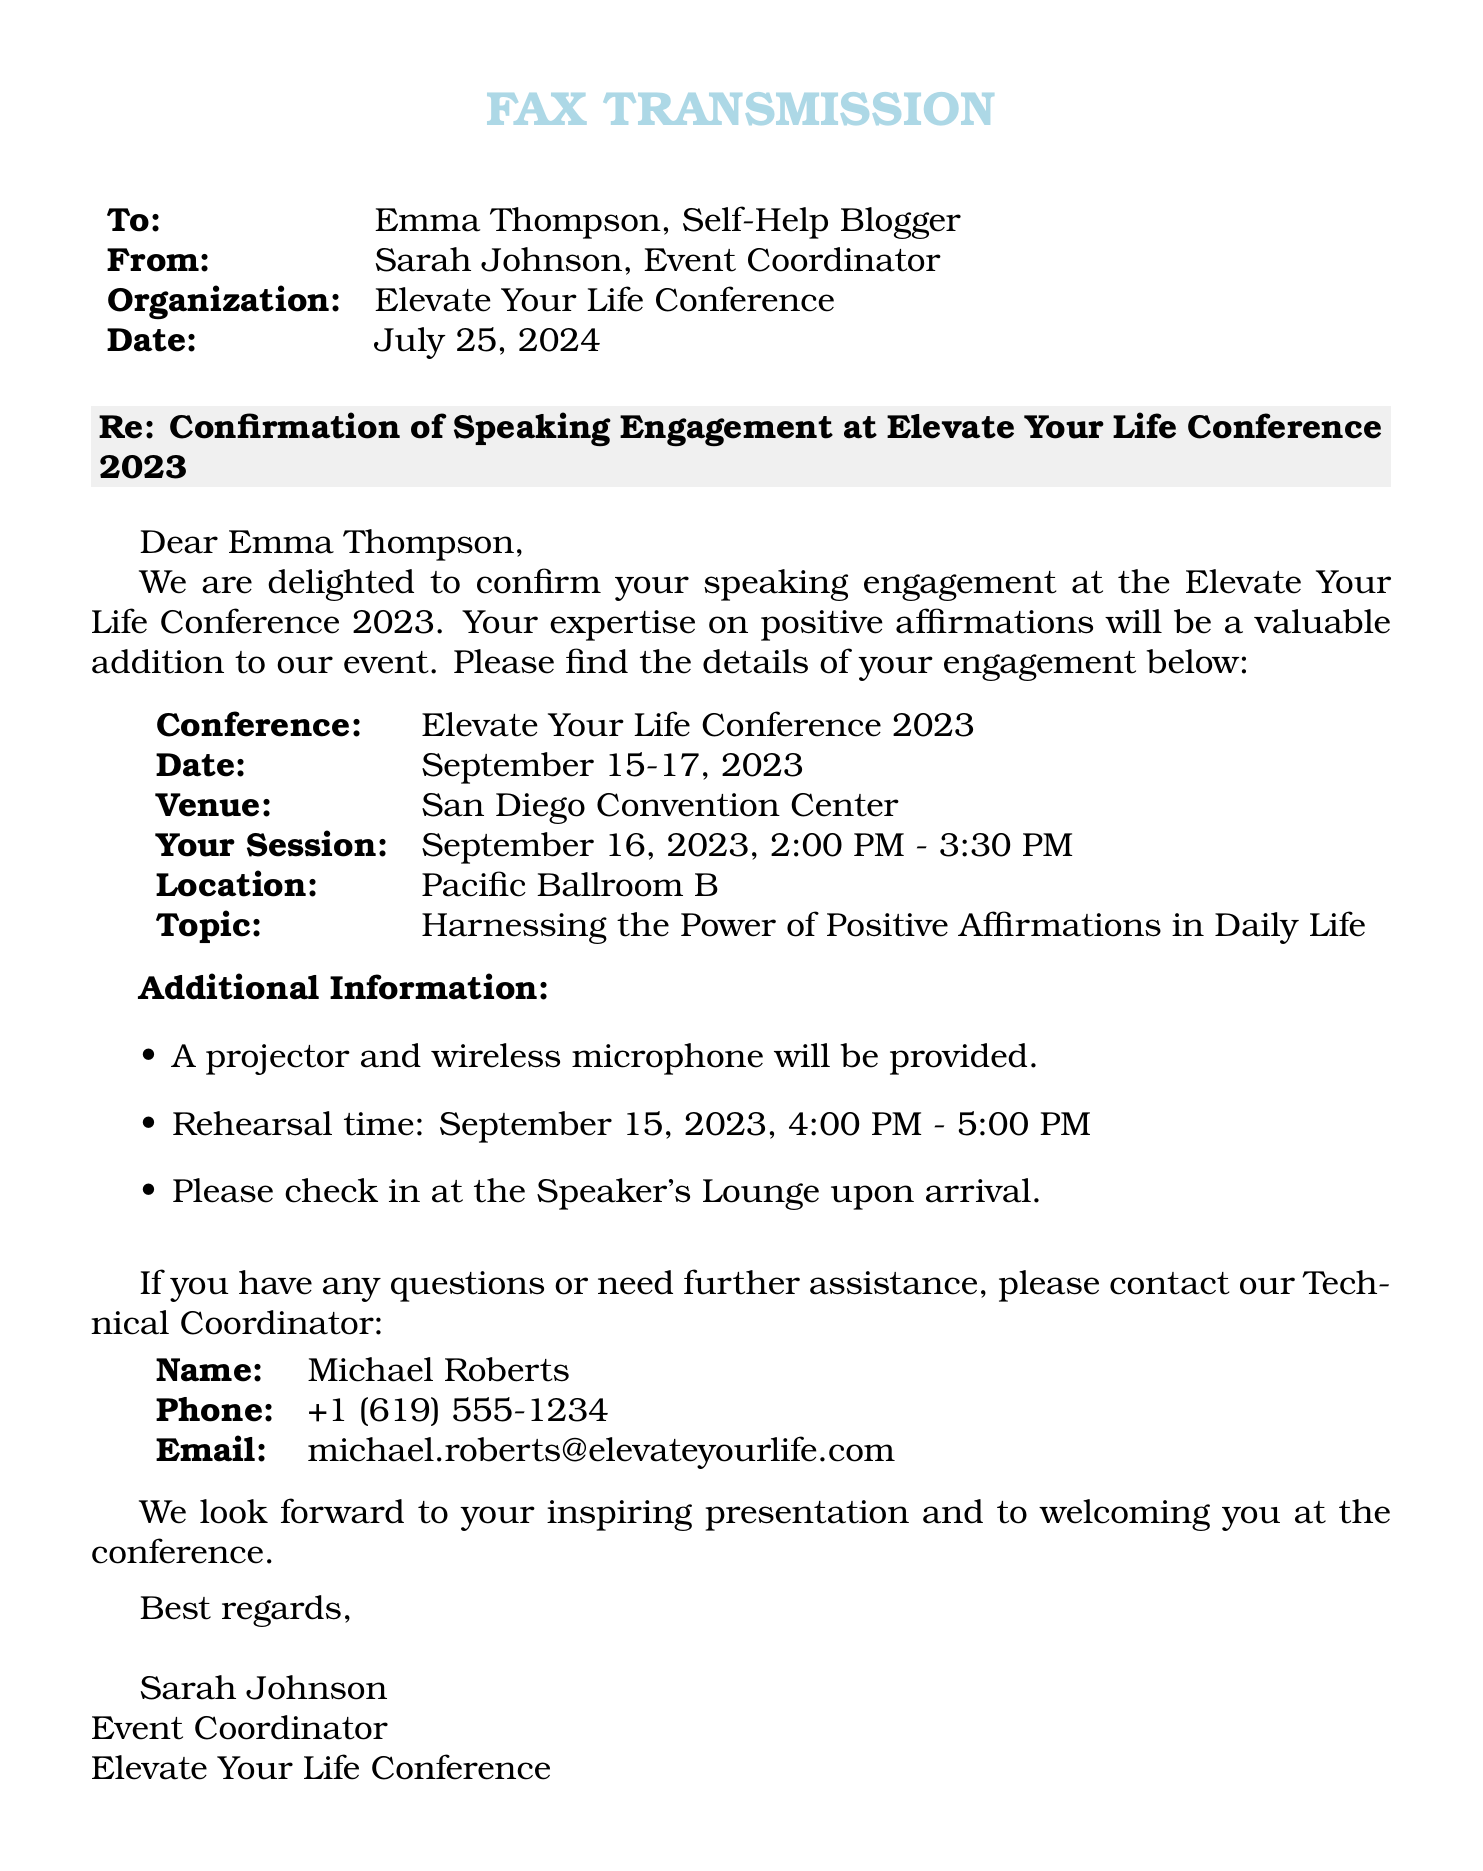What is the date of the conference? The conference is scheduled for September 15-17, 2023.
Answer: September 15-17, 2023 What is the topic of your session? The topic listed for the session is "Harnessing the Power of Positive Affirmations in Daily Life."
Answer: Harnessing the Power of Positive Affirmations in Daily Life What time is your session? The session is from 2:00 PM to 3:30 PM on September 16, 2023.
Answer: 2:00 PM - 3:30 PM Where will the session take place? The location of the session is specified as Pacific Ballroom B.
Answer: Pacific Ballroom B Who is the Technical Coordinator? The document provides the name of the Technical Coordinator as Michael Roberts.
Answer: Michael Roberts What equipment will be provided for the session? A projector and a wireless microphone are mentioned as provided equipment.
Answer: Projector and wireless microphone When is the rehearsal time? The rehearsal time is stated as September 15, 2023, from 4:00 PM to 5:00 PM.
Answer: September 15, 2023, 4:00 PM - 5:00 PM Who should be contacted for further assistance? The person designated for inquiries is Michael Roberts, as stated in the document.
Answer: Michael Roberts 